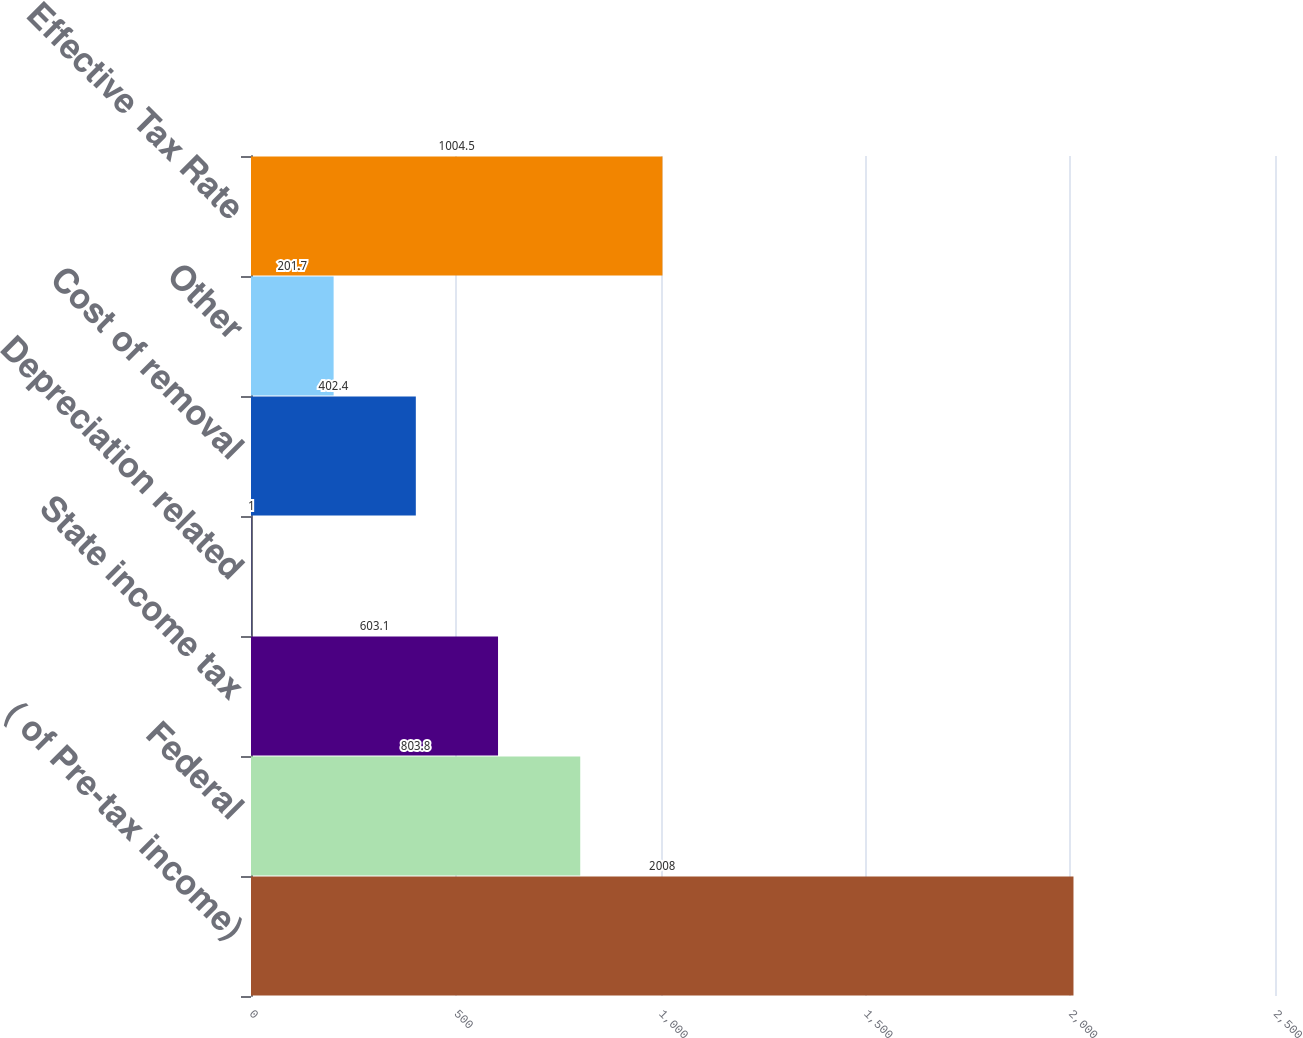<chart> <loc_0><loc_0><loc_500><loc_500><bar_chart><fcel>( of Pre-tax income)<fcel>Federal<fcel>State income tax<fcel>Depreciation related<fcel>Cost of removal<fcel>Other<fcel>Effective Tax Rate<nl><fcel>2008<fcel>803.8<fcel>603.1<fcel>1<fcel>402.4<fcel>201.7<fcel>1004.5<nl></chart> 